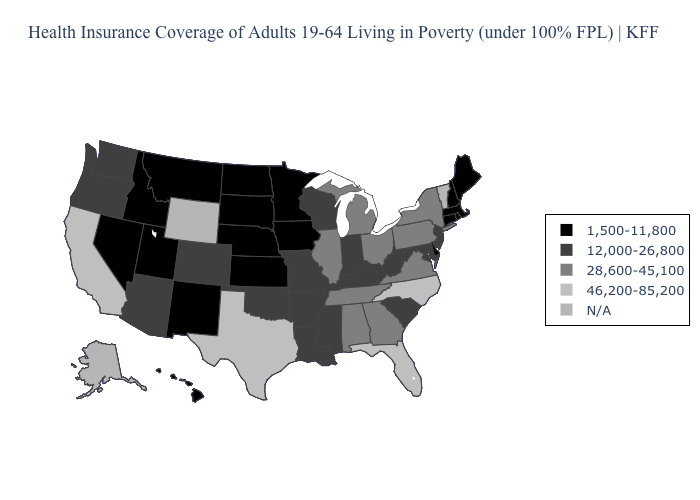Which states hav the highest value in the West?
Short answer required. California. What is the value of Maryland?
Write a very short answer. 12,000-26,800. What is the value of Michigan?
Quick response, please. 28,600-45,100. Name the states that have a value in the range 46,200-85,200?
Quick response, please. California, Florida, North Carolina, Texas. Name the states that have a value in the range 12,000-26,800?
Give a very brief answer. Arizona, Arkansas, Colorado, Indiana, Kentucky, Louisiana, Maryland, Mississippi, Missouri, New Jersey, Oklahoma, Oregon, South Carolina, Washington, West Virginia, Wisconsin. Name the states that have a value in the range 1,500-11,800?
Answer briefly. Connecticut, Delaware, Hawaii, Idaho, Iowa, Kansas, Maine, Massachusetts, Minnesota, Montana, Nebraska, Nevada, New Hampshire, New Mexico, North Dakota, Rhode Island, South Dakota, Utah. Name the states that have a value in the range 46,200-85,200?
Short answer required. California, Florida, North Carolina, Texas. Name the states that have a value in the range 1,500-11,800?
Write a very short answer. Connecticut, Delaware, Hawaii, Idaho, Iowa, Kansas, Maine, Massachusetts, Minnesota, Montana, Nebraska, Nevada, New Hampshire, New Mexico, North Dakota, Rhode Island, South Dakota, Utah. Among the states that border Connecticut , which have the lowest value?
Concise answer only. Massachusetts, Rhode Island. Name the states that have a value in the range 28,600-45,100?
Short answer required. Alabama, Georgia, Illinois, Michigan, New York, Ohio, Pennsylvania, Tennessee, Virginia. Does the first symbol in the legend represent the smallest category?
Short answer required. Yes. What is the lowest value in the West?
Keep it brief. 1,500-11,800. Does Montana have the lowest value in the West?
Concise answer only. Yes. How many symbols are there in the legend?
Be succinct. 5. How many symbols are there in the legend?
Short answer required. 5. 